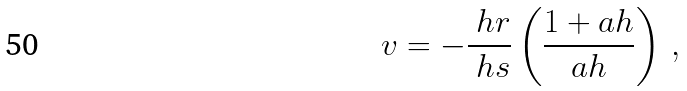<formula> <loc_0><loc_0><loc_500><loc_500>v = - \frac { \ h r } { \ h s } \left ( \frac { 1 + a h } { a h } \right ) \, ,</formula> 